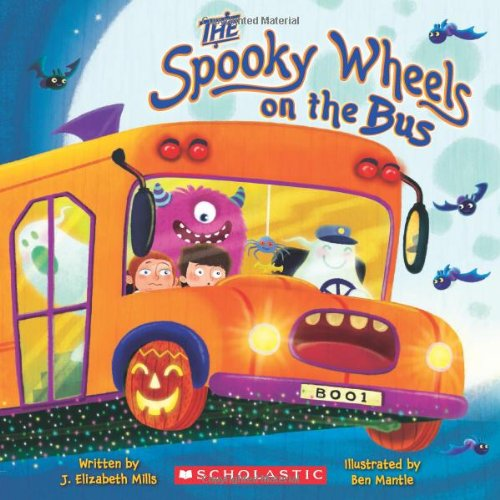Can you describe a key element or theme in this book? One of the key themes of 'The Spooky Wheels on the Bus' is the fun and whimsical take on Halloween, characterized by its playful ghosts, monsters, and other Halloween figures taking a ride on a bus, which is creatively portrayed in a non-scary manner suitable for children. 